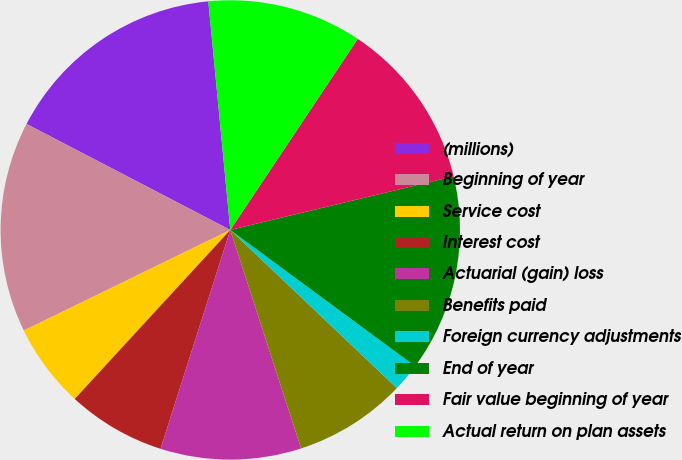Convert chart. <chart><loc_0><loc_0><loc_500><loc_500><pie_chart><fcel>(millions)<fcel>Beginning of year<fcel>Service cost<fcel>Interest cost<fcel>Actuarial (gain) loss<fcel>Benefits paid<fcel>Foreign currency adjustments<fcel>End of year<fcel>Fair value beginning of year<fcel>Actual return on plan assets<nl><fcel>15.84%<fcel>14.85%<fcel>5.94%<fcel>6.93%<fcel>9.9%<fcel>7.92%<fcel>1.98%<fcel>13.86%<fcel>11.88%<fcel>10.89%<nl></chart> 